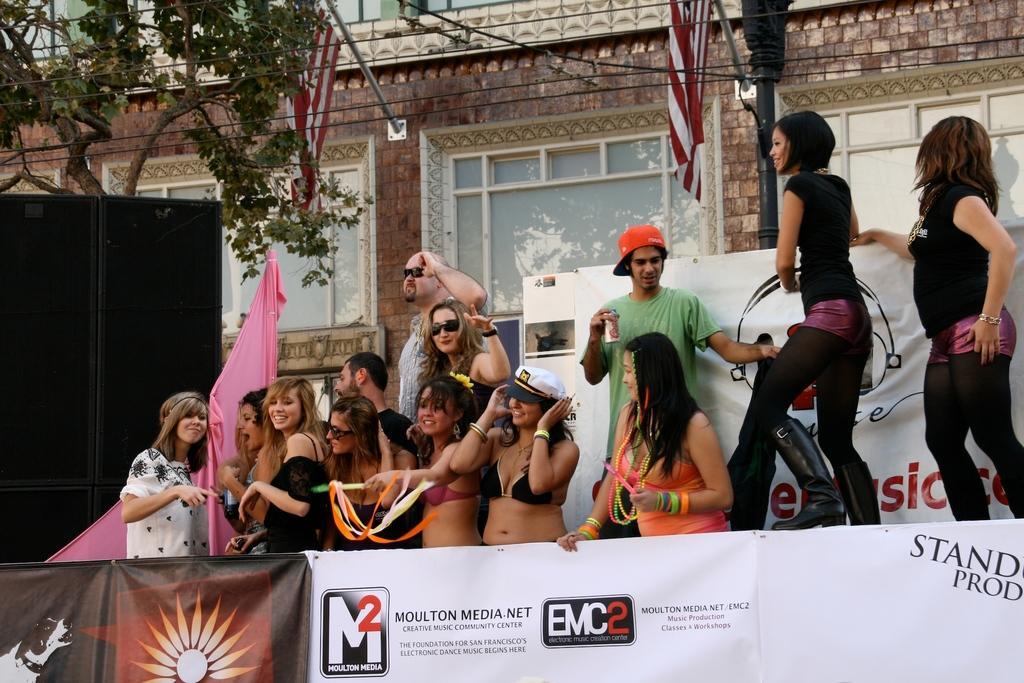In one or two sentences, can you explain what this image depicts? At the bottom we can see hoarding and there are few persons standing at the hoarding, cloth. In the background there are speakers, tree, wires, building, flags to the poles on the wall, windows, hoarding and a pole. 